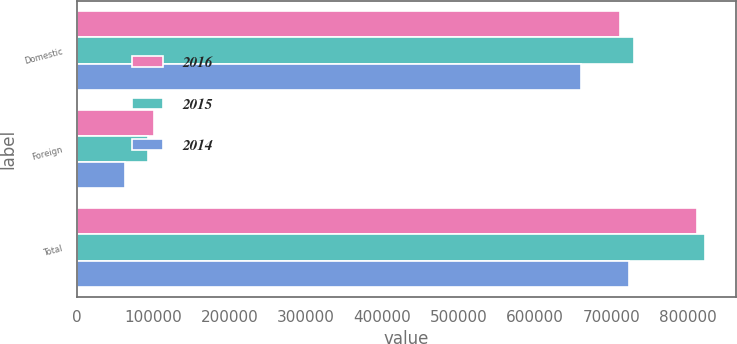<chart> <loc_0><loc_0><loc_500><loc_500><stacked_bar_chart><ecel><fcel>Domestic<fcel>Foreign<fcel>Total<nl><fcel>2016<fcel>710931<fcel>101019<fcel>811950<nl><fcel>2015<fcel>729390<fcel>93391<fcel>822781<nl><fcel>2014<fcel>659996<fcel>63435<fcel>723431<nl></chart> 